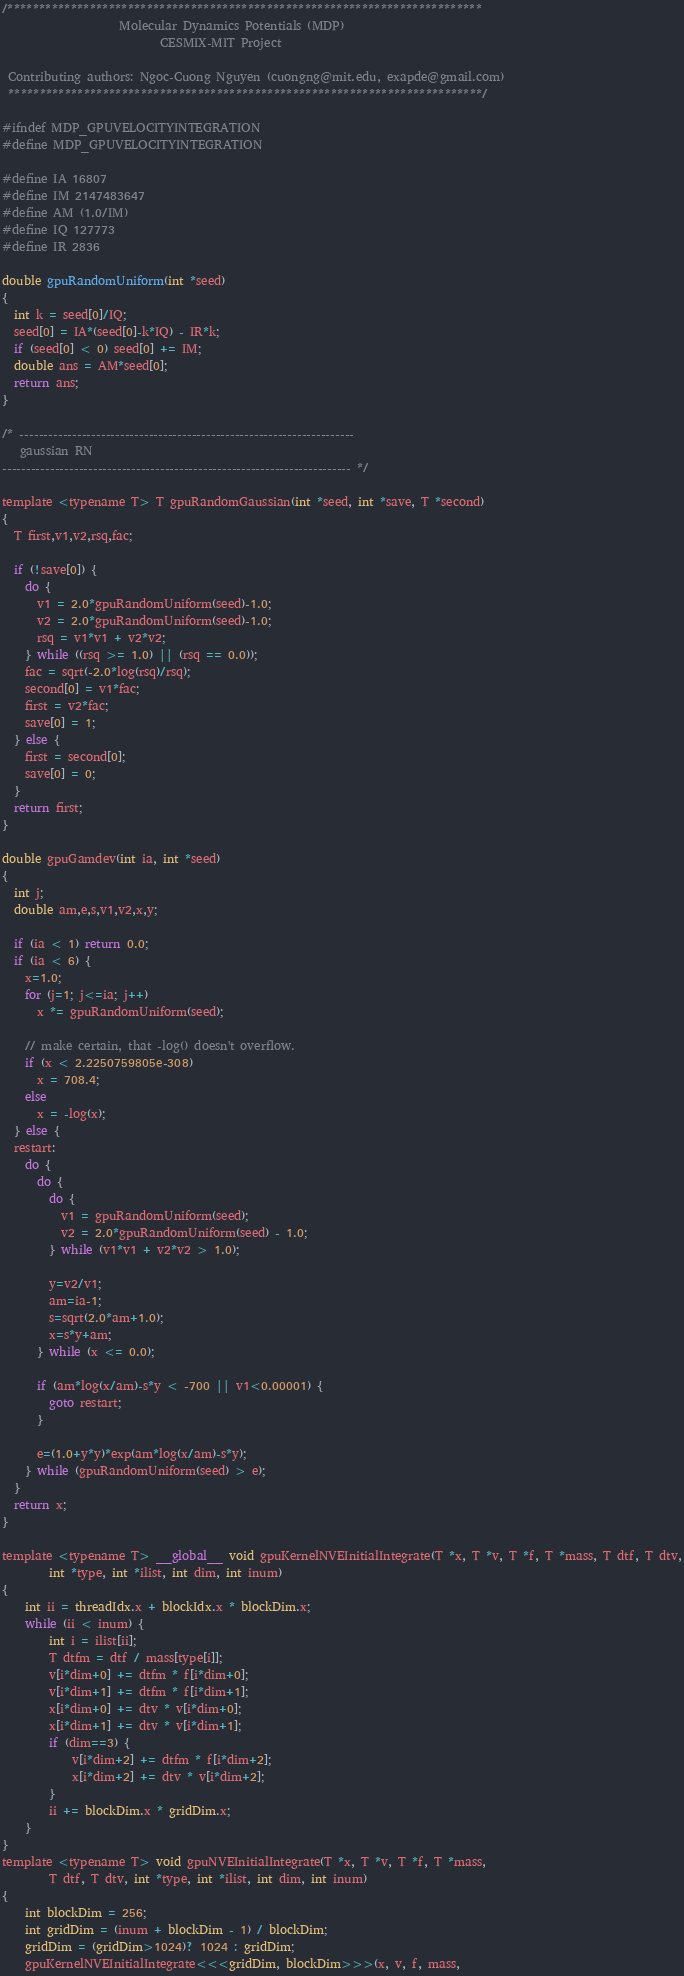<code> <loc_0><loc_0><loc_500><loc_500><_Cuda_>/***************************************************************************                               
                    Molecular Dynamics Potentials (MDP)
                           CESMIX-MIT Project  
 
 Contributing authors: Ngoc-Cuong Nguyen (cuongng@mit.edu, exapde@gmail.com)
 ***************************************************************************/
               
#ifndef MDP_GPUVELOCITYINTEGRATION
#define MDP_GPUVELOCITYINTEGRATION

#define IA 16807
#define IM 2147483647
#define AM (1.0/IM)
#define IQ 127773
#define IR 2836
        
double gpuRandomUniform(int *seed)
{
  int k = seed[0]/IQ;
  seed[0] = IA*(seed[0]-k*IQ) - IR*k;
  if (seed[0] < 0) seed[0] += IM;
  double ans = AM*seed[0];
  return ans;
}

/* ----------------------------------------------------------------------
   gaussian RN
------------------------------------------------------------------------- */

template <typename T> T gpuRandomGaussian(int *seed, int *save, T *second)
{
  T first,v1,v2,rsq,fac;

  if (!save[0]) {
    do {
      v1 = 2.0*gpuRandomUniform(seed)-1.0;
      v2 = 2.0*gpuRandomUniform(seed)-1.0;
      rsq = v1*v1 + v2*v2;
    } while ((rsq >= 1.0) || (rsq == 0.0));
    fac = sqrt(-2.0*log(rsq)/rsq);
    second[0] = v1*fac;
    first = v2*fac;
    save[0] = 1;
  } else {
    first = second[0];
    save[0] = 0;
  }
  return first;
}

double gpuGamdev(int ia, int *seed)
{
  int j;
  double am,e,s,v1,v2,x,y;

  if (ia < 1) return 0.0;
  if (ia < 6) {
    x=1.0;
    for (j=1; j<=ia; j++)
      x *= gpuRandomUniform(seed);

    // make certain, that -log() doesn't overflow.
    if (x < 2.2250759805e-308)
      x = 708.4;
    else
      x = -log(x);
  } else {
  restart:
    do {
      do {
        do {
          v1 = gpuRandomUniform(seed);
          v2 = 2.0*gpuRandomUniform(seed) - 1.0;
        } while (v1*v1 + v2*v2 > 1.0);

        y=v2/v1;
        am=ia-1;
        s=sqrt(2.0*am+1.0);
        x=s*y+am;
      } while (x <= 0.0);

      if (am*log(x/am)-s*y < -700 || v1<0.00001) {
        goto restart;
      }

      e=(1.0+y*y)*exp(am*log(x/am)-s*y);
    } while (gpuRandomUniform(seed) > e);
  }
  return x;
}

template <typename T> __global__ void gpuKernelNVEInitialIntegrate(T *x, T *v, T *f, T *mass, T dtf, T dtv,
        int *type, int *ilist, int dim, int inum)
{
    int ii = threadIdx.x + blockIdx.x * blockDim.x;
    while (ii < inum) {
        int i = ilist[ii]; 
        T dtfm = dtf / mass[type[i]];
        v[i*dim+0] += dtfm * f[i*dim+0];
        v[i*dim+1] += dtfm * f[i*dim+1];
        x[i*dim+0] += dtv * v[i*dim+0];
        x[i*dim+1] += dtv * v[i*dim+1];        
        if (dim==3) {
            v[i*dim+2] += dtfm * f[i*dim+2];
            x[i*dim+2] += dtv * v[i*dim+2];
        }                
        ii += blockDim.x * gridDim.x;
    }  
}
template <typename T> void gpuNVEInitialIntegrate(T *x, T *v, T *f, T *mass, 
        T dtf, T dtv, int *type, int *ilist, int dim, int inum)
{        
    int blockDim = 256;
    int gridDim = (inum + blockDim - 1) / blockDim;
    gridDim = (gridDim>1024)? 1024 : gridDim;
    gpuKernelNVEInitialIntegrate<<<gridDim, blockDim>>>(x, v, f, mass, </code> 